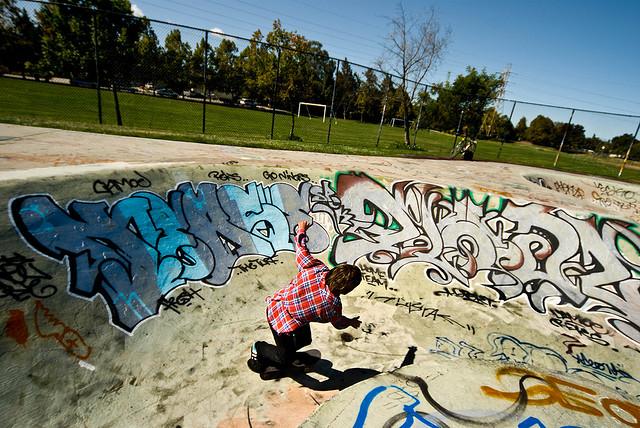Do you see graffiti?
Quick response, please. Yes. Does the weather appear warm?
Keep it brief. Yes. Is the skater skating in a man made skate park?
Keep it brief. Yes. Why is the man's shadow beneath him?
Concise answer only. Yes. 